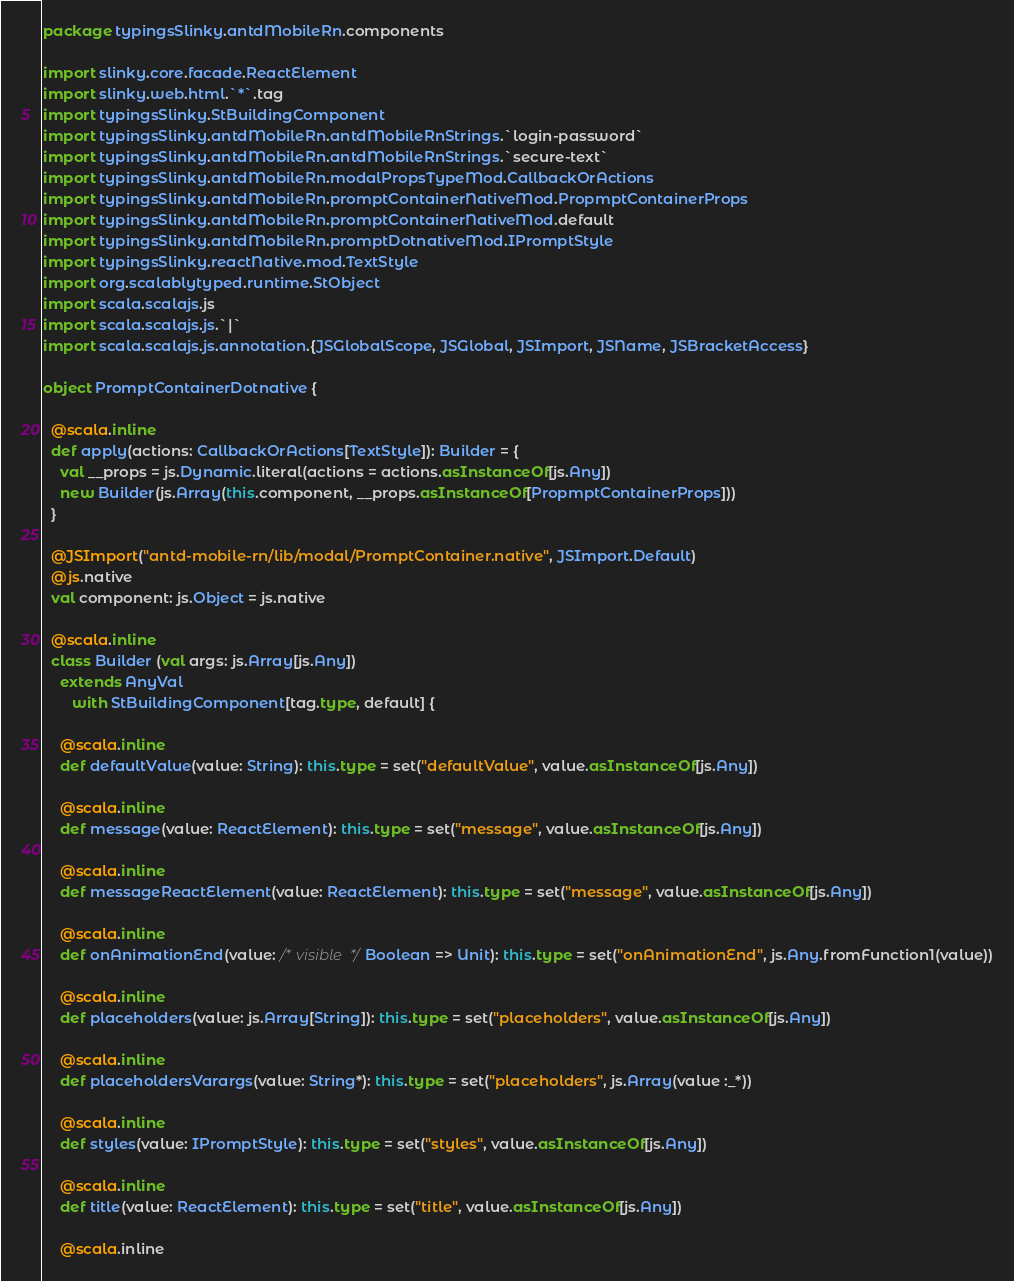Convert code to text. <code><loc_0><loc_0><loc_500><loc_500><_Scala_>package typingsSlinky.antdMobileRn.components

import slinky.core.facade.ReactElement
import slinky.web.html.`*`.tag
import typingsSlinky.StBuildingComponent
import typingsSlinky.antdMobileRn.antdMobileRnStrings.`login-password`
import typingsSlinky.antdMobileRn.antdMobileRnStrings.`secure-text`
import typingsSlinky.antdMobileRn.modalPropsTypeMod.CallbackOrActions
import typingsSlinky.antdMobileRn.promptContainerNativeMod.PropmptContainerProps
import typingsSlinky.antdMobileRn.promptContainerNativeMod.default
import typingsSlinky.antdMobileRn.promptDotnativeMod.IPromptStyle
import typingsSlinky.reactNative.mod.TextStyle
import org.scalablytyped.runtime.StObject
import scala.scalajs.js
import scala.scalajs.js.`|`
import scala.scalajs.js.annotation.{JSGlobalScope, JSGlobal, JSImport, JSName, JSBracketAccess}

object PromptContainerDotnative {
  
  @scala.inline
  def apply(actions: CallbackOrActions[TextStyle]): Builder = {
    val __props = js.Dynamic.literal(actions = actions.asInstanceOf[js.Any])
    new Builder(js.Array(this.component, __props.asInstanceOf[PropmptContainerProps]))
  }
  
  @JSImport("antd-mobile-rn/lib/modal/PromptContainer.native", JSImport.Default)
  @js.native
  val component: js.Object = js.native
  
  @scala.inline
  class Builder (val args: js.Array[js.Any])
    extends AnyVal
       with StBuildingComponent[tag.type, default] {
    
    @scala.inline
    def defaultValue(value: String): this.type = set("defaultValue", value.asInstanceOf[js.Any])
    
    @scala.inline
    def message(value: ReactElement): this.type = set("message", value.asInstanceOf[js.Any])
    
    @scala.inline
    def messageReactElement(value: ReactElement): this.type = set("message", value.asInstanceOf[js.Any])
    
    @scala.inline
    def onAnimationEnd(value: /* visible */ Boolean => Unit): this.type = set("onAnimationEnd", js.Any.fromFunction1(value))
    
    @scala.inline
    def placeholders(value: js.Array[String]): this.type = set("placeholders", value.asInstanceOf[js.Any])
    
    @scala.inline
    def placeholdersVarargs(value: String*): this.type = set("placeholders", js.Array(value :_*))
    
    @scala.inline
    def styles(value: IPromptStyle): this.type = set("styles", value.asInstanceOf[js.Any])
    
    @scala.inline
    def title(value: ReactElement): this.type = set("title", value.asInstanceOf[js.Any])
    
    @scala.inline</code> 